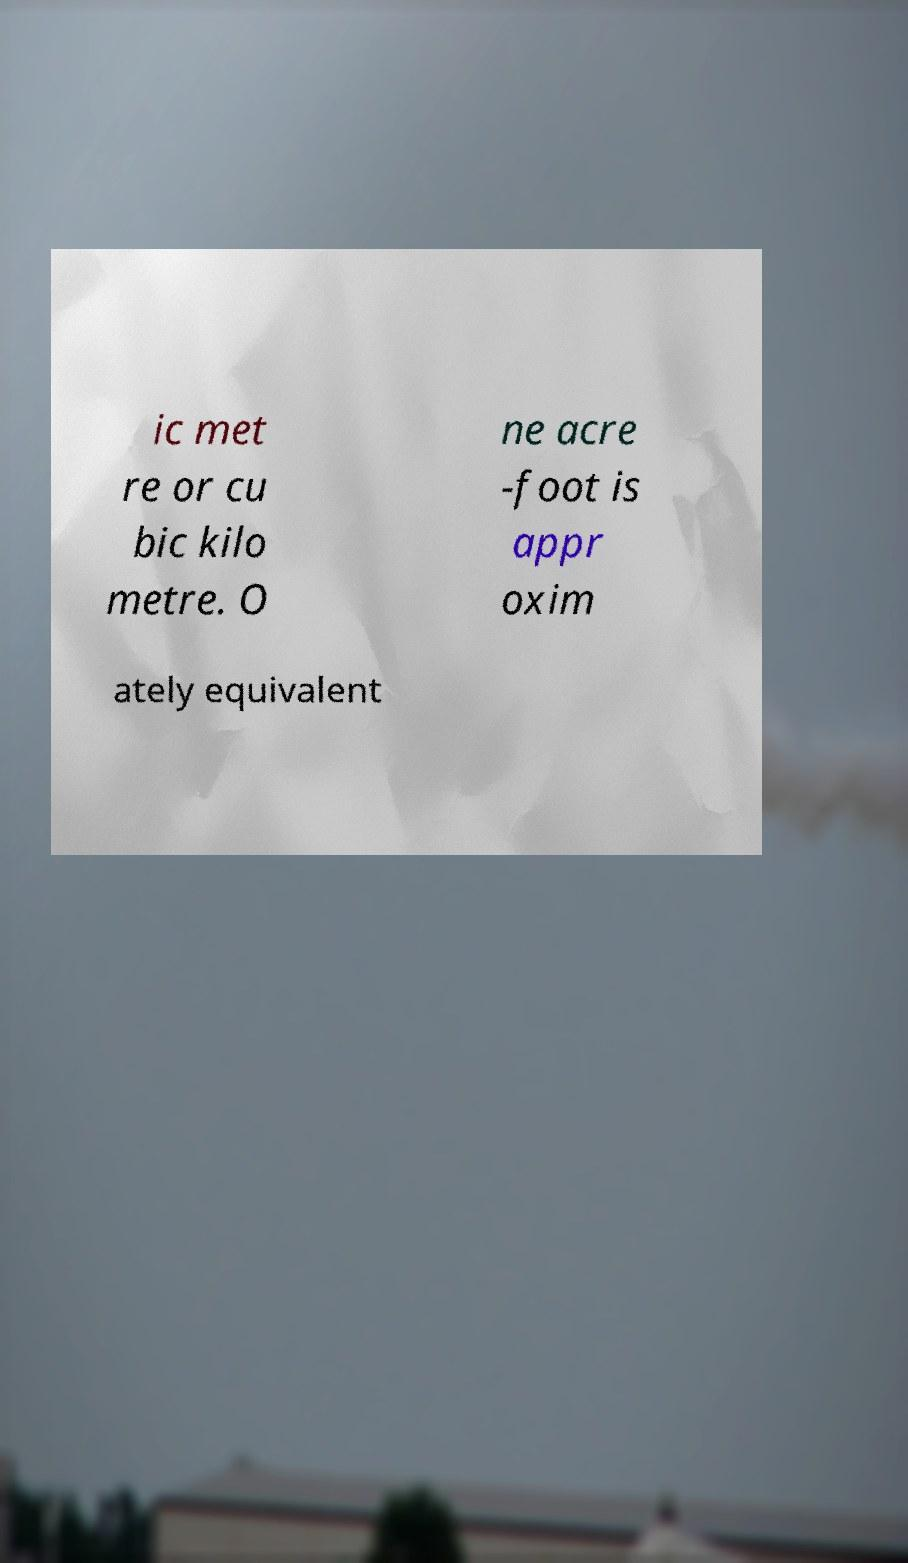What messages or text are displayed in this image? I need them in a readable, typed format. ic met re or cu bic kilo metre. O ne acre -foot is appr oxim ately equivalent 